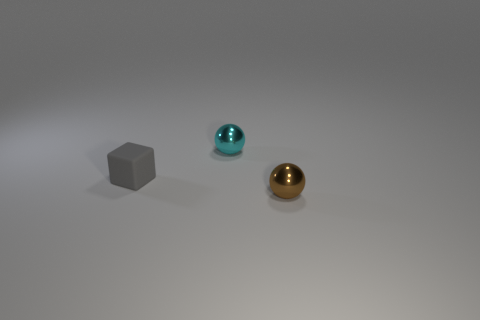Can you describe the three objects on the surface and their arrangement? Certainly! There are three distinct objects laid out in a diagonal line. Starting from the left, there's a matte gray cube, followed by a glossy cyan sphere, and finally, a shiny gold sphere to the right. 